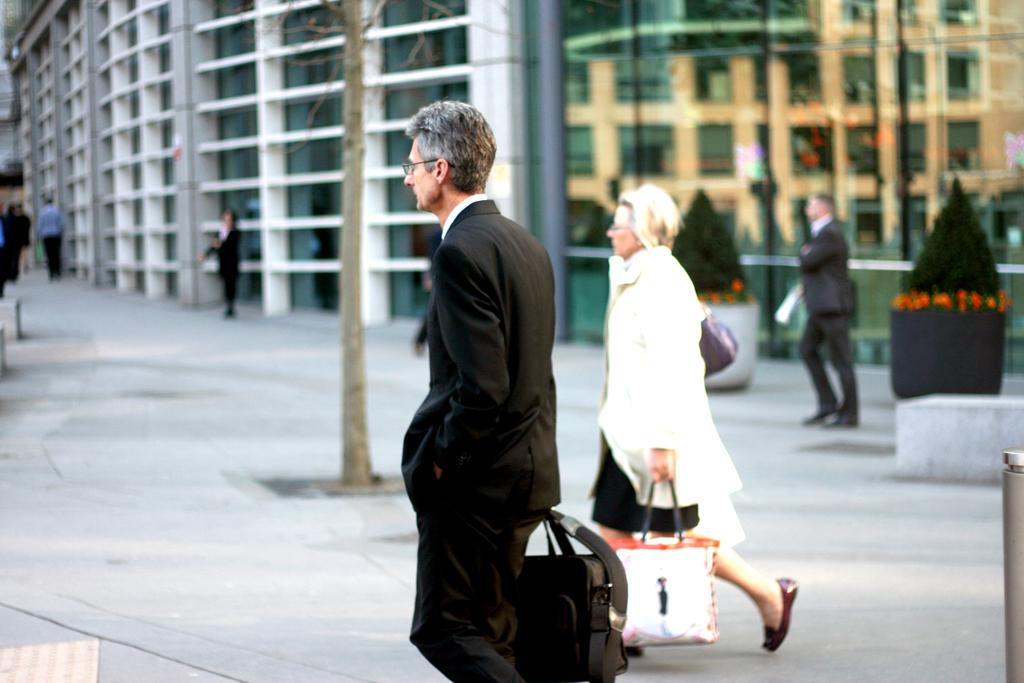What is the man in the image wearing? The man is wearing a black suit. What is the man holding in the image? The man is holding a bag. What is the man doing in the image? The man is walking. What is the lady in the image wearing? The lady is wearing a white dress. What is the lady holding in the image? The lady is holding a bag. What is the lady doing in the image? The lady is walking. What can be seen in the background of the image? There is a building and a tree in the background of the image. How many people are visible in the background of the image? There are many persons visible in the background of the image. What type of growth can be seen on the man's dress in the image? There is no growth on the man's dress in the image, as he is wearing a suit, not a dress. 